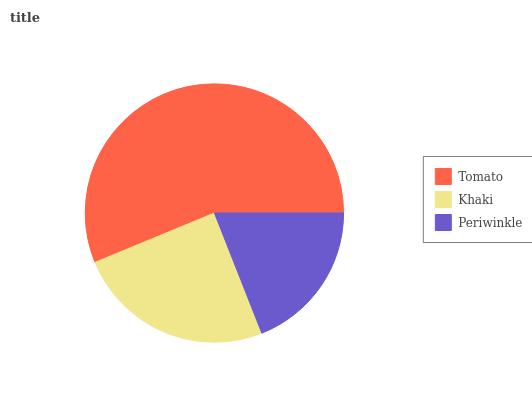Is Periwinkle the minimum?
Answer yes or no. Yes. Is Tomato the maximum?
Answer yes or no. Yes. Is Khaki the minimum?
Answer yes or no. No. Is Khaki the maximum?
Answer yes or no. No. Is Tomato greater than Khaki?
Answer yes or no. Yes. Is Khaki less than Tomato?
Answer yes or no. Yes. Is Khaki greater than Tomato?
Answer yes or no. No. Is Tomato less than Khaki?
Answer yes or no. No. Is Khaki the high median?
Answer yes or no. Yes. Is Khaki the low median?
Answer yes or no. Yes. Is Tomato the high median?
Answer yes or no. No. Is Tomato the low median?
Answer yes or no. No. 